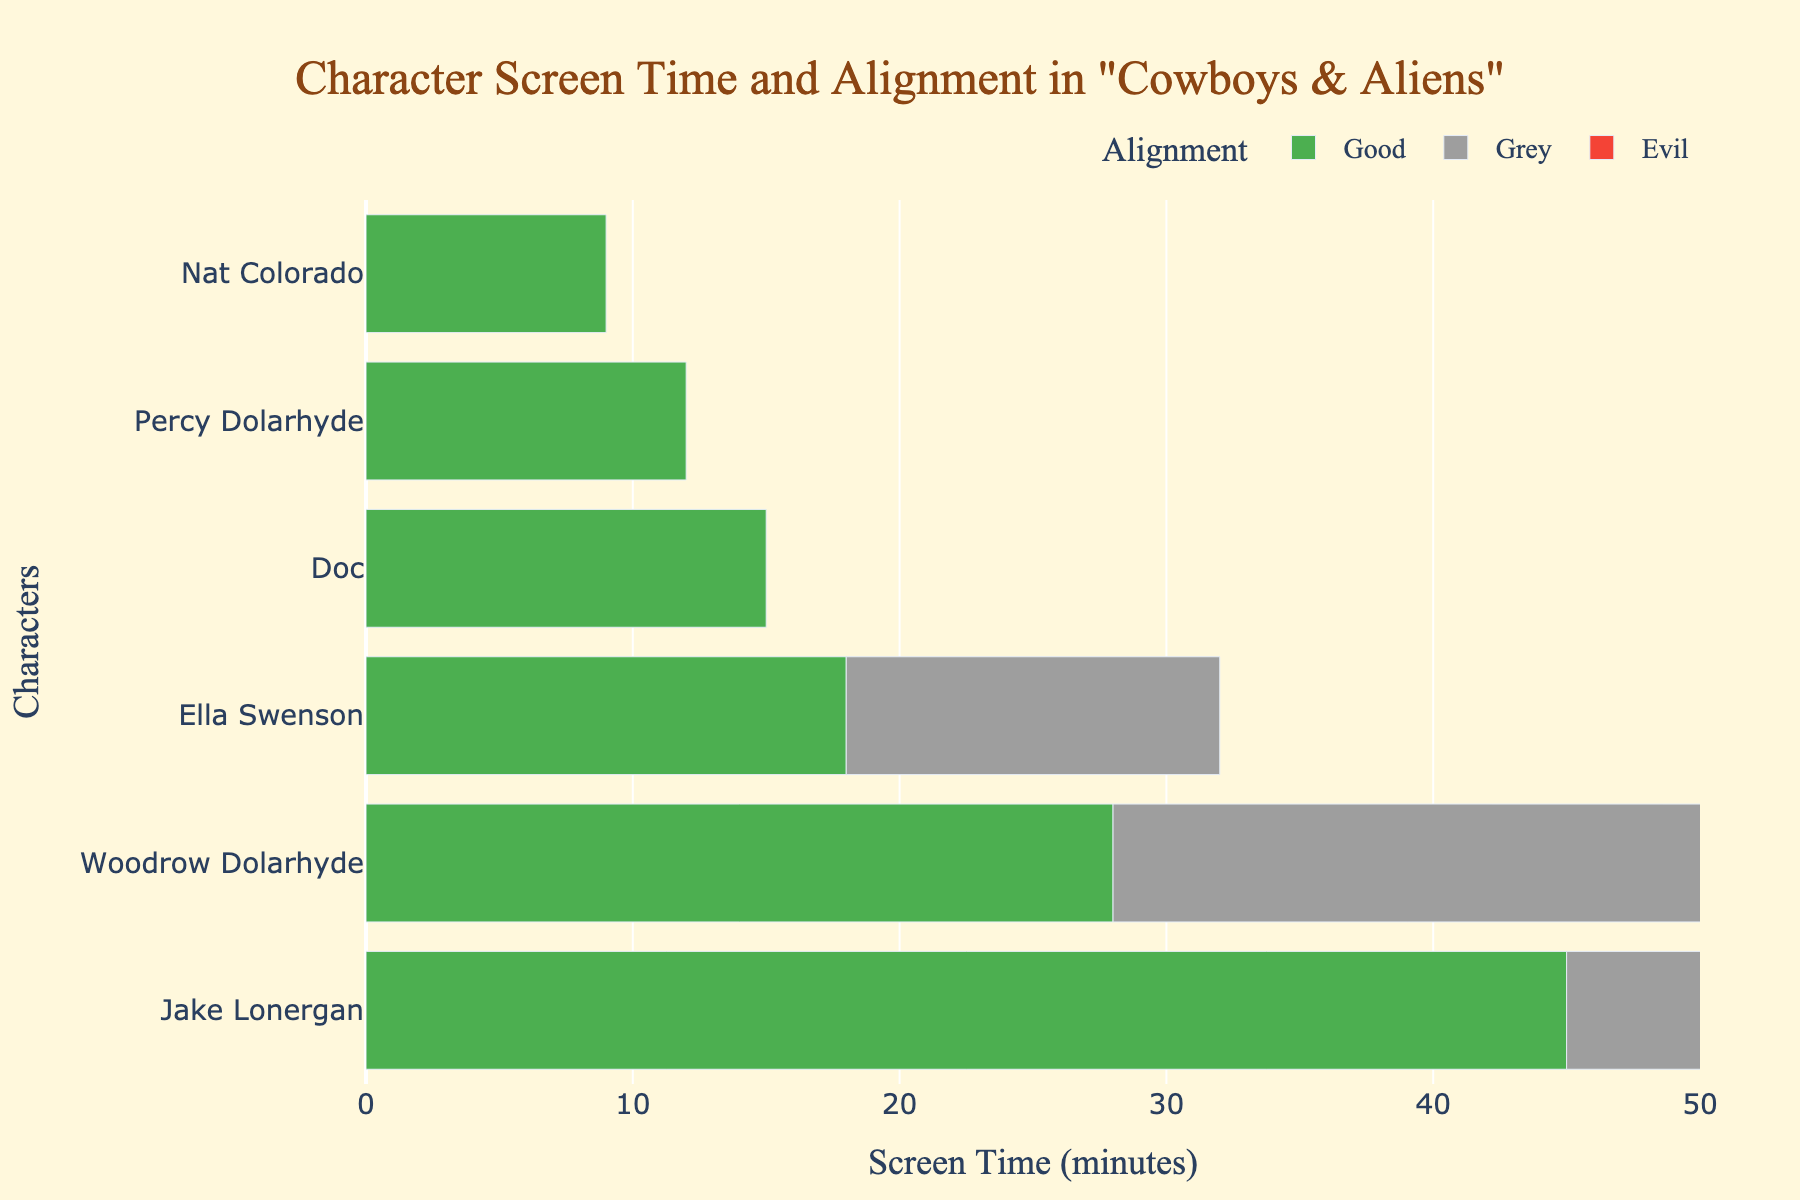Which character has the most screen time? The character with the longest bar represents the most screen time. Jake Lonergan's bar is the longest.
Answer: Jake Lonergan How much screen time does Percy Dolarhyde have compared to Nat Colorado? Percy Dolarhyde's bar is 20 minutes long, while Nat Colorado's bar is 18 minutes long. Percy has 2 minutes more screen time than Nat.
Answer: 2 minutes more Which alignment appears most frequently among the top 5 characters by screen time? Look at the top 5 longest bars and check their colors: Jake Lonergan (Good), Woodrow Dolarhyde (Grey), Ella Swenson (Good), Doc (Grey), Percy Dolarhyde (Evil). 'Good' and 'Grey' appears twice each.
Answer: Good and Grey What is the total screen time of all characters with an 'Evil' alignment? Sum the screen time for Percy Dolarhyde (20) and Pat Dolan (8). Total screen time is 20 + 8 = 28 minutes.
Answer: 28 minutes Find the character with the least screen time and their alignment. The shortest bar belongs to Pat Dolan who has 8 minutes of screen time and is aligned as 'Evil'.
Answer: Pat Dolan, Evil What is the average screen time for characters with 'Grey' alignment? The characters with 'Grey' alignment are Woodrow Dolarhyde (37), Doc (25), and Meacham (14). Average screen time is (37 + 25 + 14) / 3 = 76 / 3 ≈ 25.33 minutes.
Answer: Approximately 25.33 minutes Which alignment color is associated with Alice Lonergan? Alice Lonergan's bar is colored green, which represents a 'Good' alignment.
Answer: Good Which characters have more than 20 minutes of screen time? Check the bars exceeding the 20-minute mark: Jake Lonergan, Woodrow Dolarhyde, Ella Swenson, and Doc.
Answer: Jake Lonergan, Woodrow Dolarhyde, Ella Swenson, Doc How much more screen time does Jake Lonergan have compared to Alice Lonergan? Jake Lonergan has 45 minutes, and Alice Lonergan has 15 minutes. The difference is 45 - 15 = 30 minutes.
Answer: 30 minutes What percentage of the total screen time does Ella Swenson have? Sum all screen times (45+37+28+25+20+18+15+14+12+9+8=231). Ella Swenson has 28 minutes. Percentage is (28 / 231) * 100 ≈ 12.12%.
Answer: Approximately 12.12% 